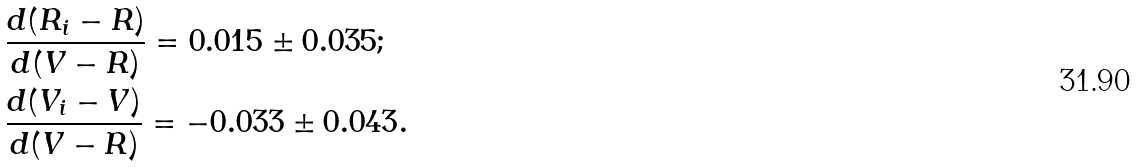<formula> <loc_0><loc_0><loc_500><loc_500>& \frac { d ( R _ { i } - R ) } { d ( V - R ) } = 0 . 0 1 5 \pm 0 . 0 3 5 ; \\ & \frac { d ( V _ { i } - V ) } { d ( V - R ) } = - 0 . 0 3 3 \pm 0 . 0 4 3 .</formula> 